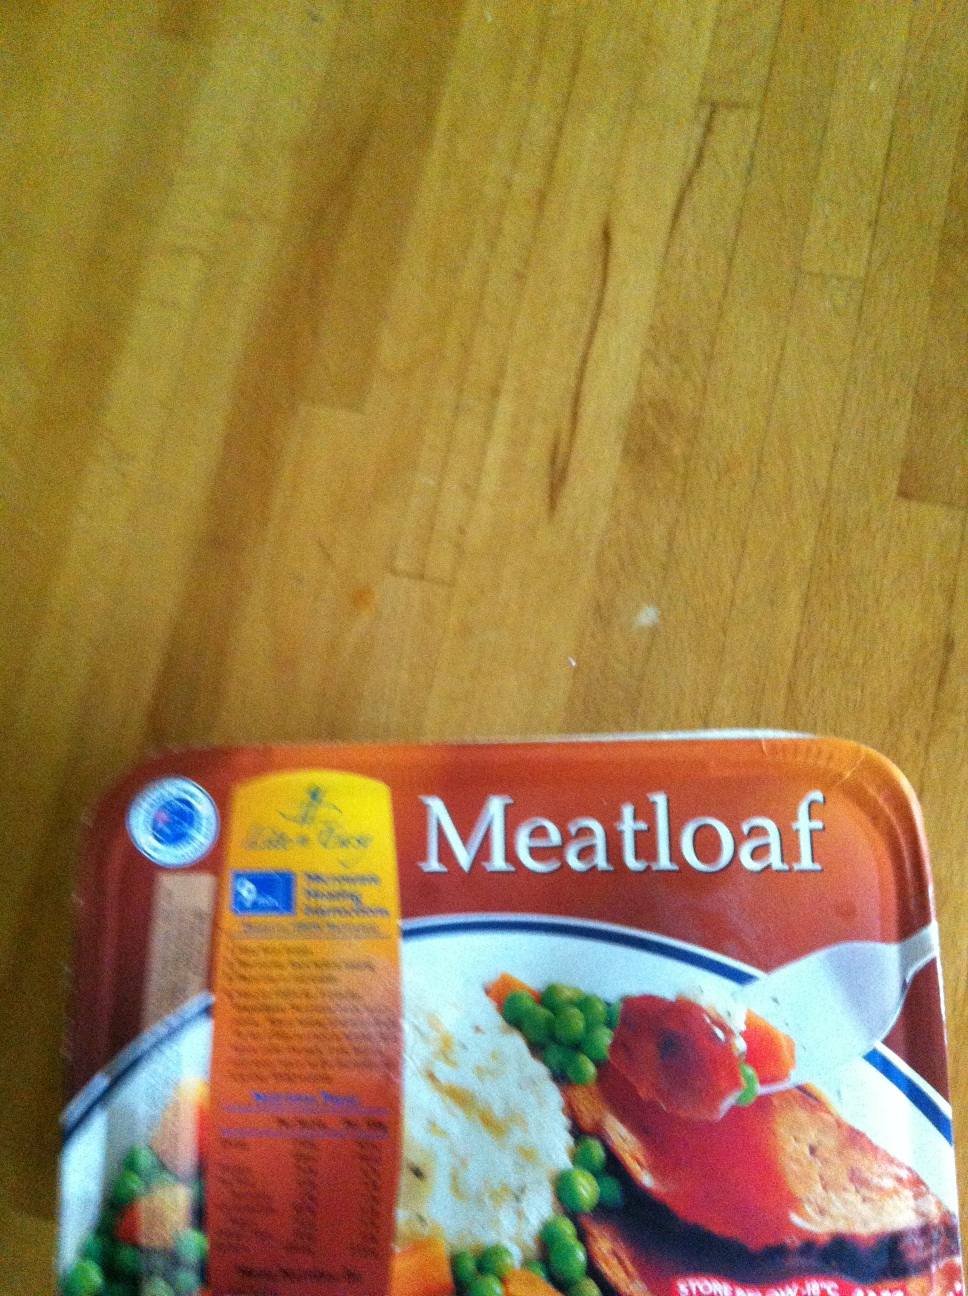Create a fun and imaginative scenario involving this meatloaf. In a whimsical world where food could talk, this meatloaf was the king of the land of Cuisine. One day, the meatloaf received a distress call from the neighboring kingdom of Veggies. A mischievous salad had brought imbalance to the culinary harmony by mixing its unwanted flavors, causing chaos across the plate. King Meatloaf, with his loyal sidekick Gravy, set out on a daring adventure to restore balance. They traversed the mountains of Mashed Potatoes, sailed through the Great Gravy River, and finally confronted the evil salad atop the Tower of Tomatoes. With a dash of seasoning and a sprinkle of herbs, King Meatloaf brought peace back to the land, ensuring every bite was delightful and full of flavor. The kingdom celebrated with a grand feast, where everyone from the smallest pea to the grandest carrot reveled in the restored harmony. 